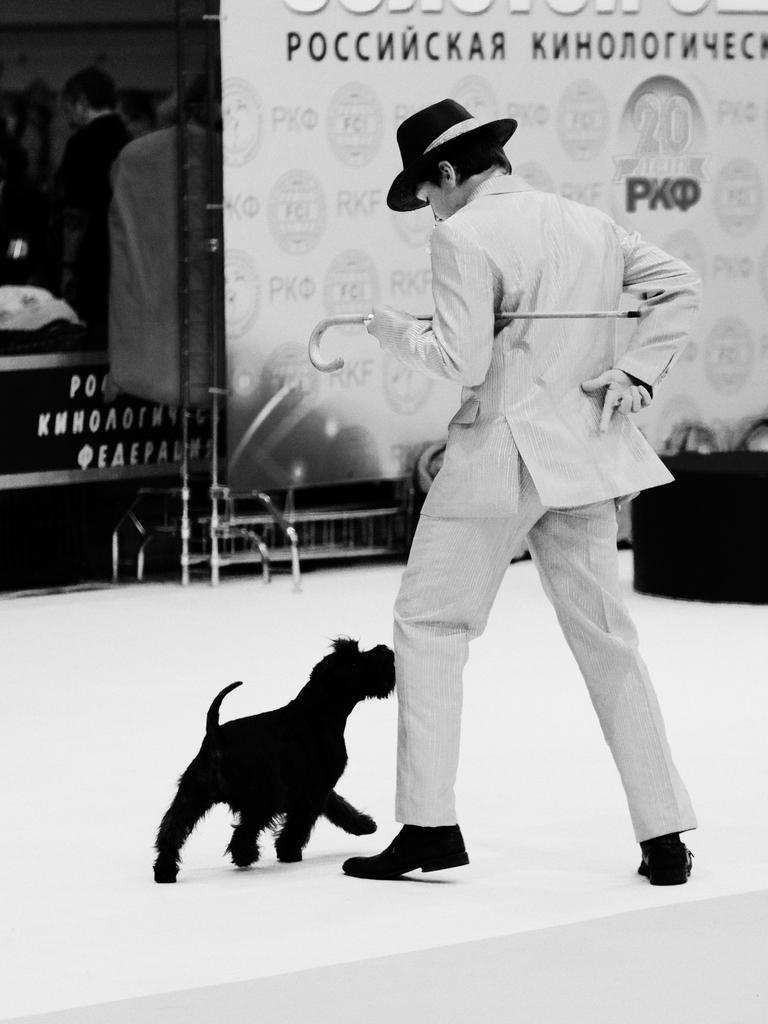Who is present in the image? There is a man in the image. What other living creature is in the image? There is a dog in the image. What is the man holding in his hands? The man is holding a stick in his hands. What type of jellyfish can be seen swimming in the background of the image? There is no jellyfish present in the image; it features a man and a dog. 